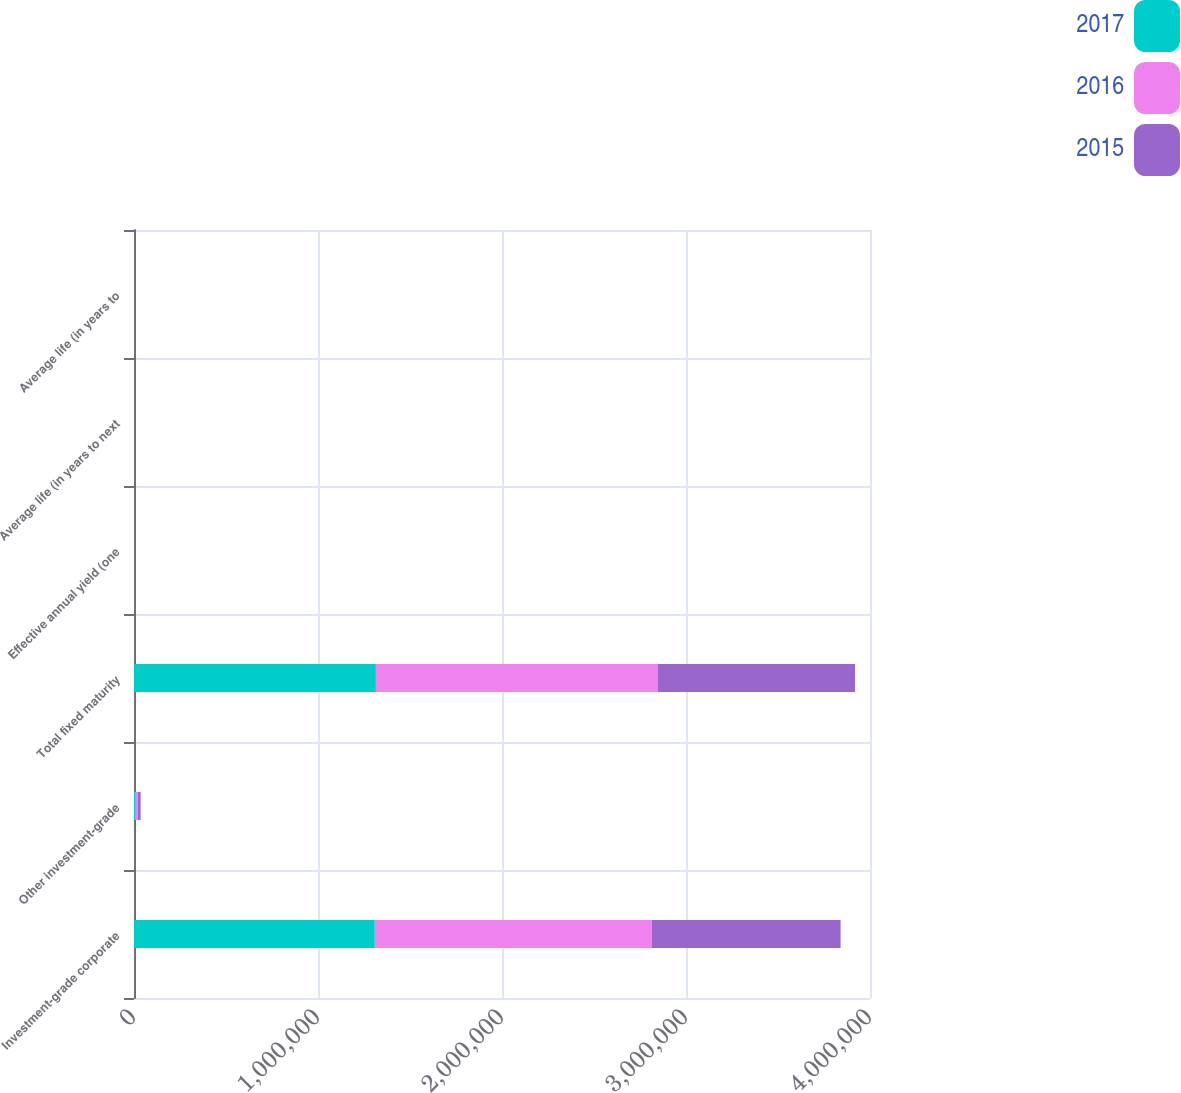Convert chart. <chart><loc_0><loc_0><loc_500><loc_500><stacked_bar_chart><ecel><fcel>Investment-grade corporate<fcel>Other investment-grade<fcel>Total fixed maturity<fcel>Effective annual yield (one<fcel>Average life (in years to next<fcel>Average life (in years to<nl><fcel>2017<fcel>1.30857e+06<fcel>6042<fcel>1.31461e+06<fcel>4.67<fcel>23<fcel>24<nl><fcel>2016<fcel>1.50514e+06<fcel>14727<fcel>1.53288e+06<fcel>4.67<fcel>24.6<fcel>25.4<nl><fcel>2015<fcel>1.02652e+06<fcel>15296<fcel>1.07091e+06<fcel>4.79<fcel>27.2<fcel>27.9<nl></chart> 